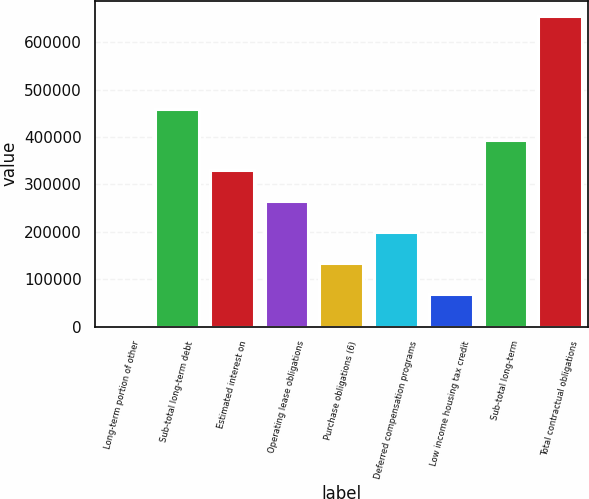<chart> <loc_0><loc_0><loc_500><loc_500><bar_chart><fcel>Long-term portion of other<fcel>Sub-total long-term debt<fcel>Estimated interest on<fcel>Operating lease obligations<fcel>Purchase obligations (6)<fcel>Deferred compensation programs<fcel>Low income housing tax credit<fcel>Sub-total long-term<fcel>Total contractual obligations<nl><fcel>5130<fcel>459686<fcel>329812<fcel>264876<fcel>135003<fcel>199940<fcel>70066.5<fcel>394749<fcel>654495<nl></chart> 